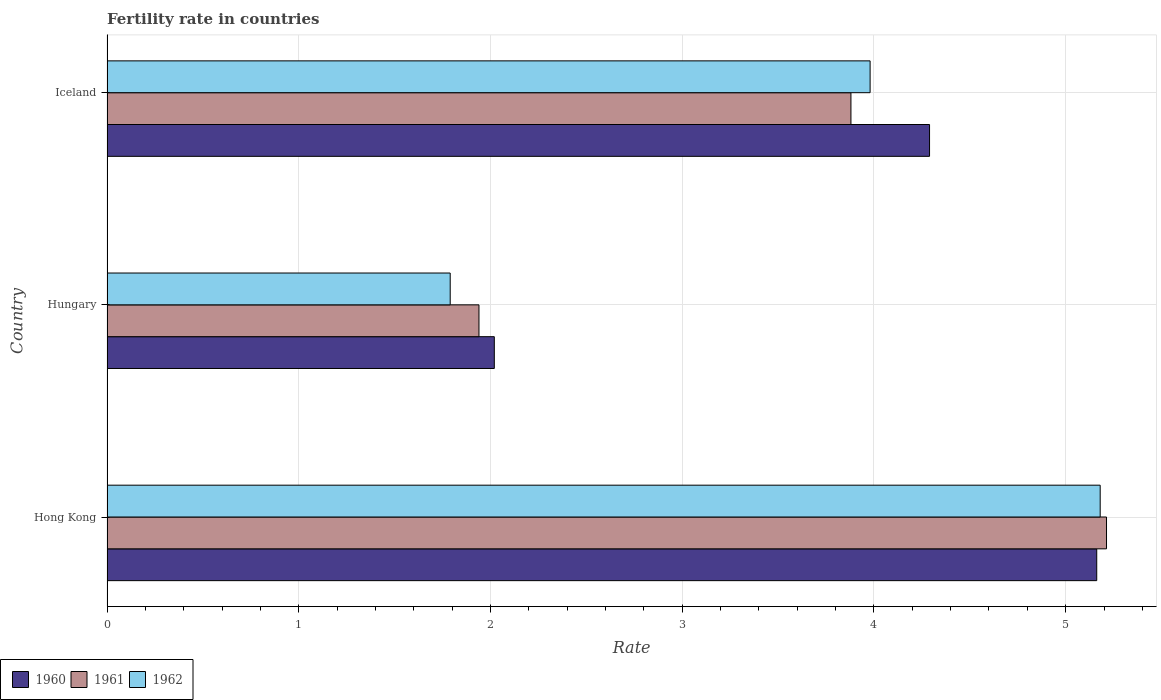How many groups of bars are there?
Your answer should be very brief. 3. How many bars are there on the 1st tick from the top?
Offer a very short reply. 3. How many bars are there on the 3rd tick from the bottom?
Offer a terse response. 3. What is the label of the 3rd group of bars from the top?
Provide a short and direct response. Hong Kong. In how many cases, is the number of bars for a given country not equal to the number of legend labels?
Provide a succinct answer. 0. What is the fertility rate in 1960 in Iceland?
Ensure brevity in your answer.  4.29. Across all countries, what is the maximum fertility rate in 1961?
Ensure brevity in your answer.  5.21. Across all countries, what is the minimum fertility rate in 1960?
Your answer should be very brief. 2.02. In which country was the fertility rate in 1962 maximum?
Your answer should be compact. Hong Kong. In which country was the fertility rate in 1960 minimum?
Provide a succinct answer. Hungary. What is the total fertility rate in 1960 in the graph?
Provide a short and direct response. 11.47. What is the difference between the fertility rate in 1962 in Hong Kong and that in Hungary?
Offer a very short reply. 3.39. What is the difference between the fertility rate in 1962 in Hong Kong and the fertility rate in 1961 in Hungary?
Your answer should be compact. 3.24. What is the average fertility rate in 1962 per country?
Your answer should be very brief. 3.65. What is the difference between the fertility rate in 1962 and fertility rate in 1961 in Hungary?
Provide a succinct answer. -0.15. What is the ratio of the fertility rate in 1962 in Hong Kong to that in Hungary?
Your answer should be very brief. 2.89. Is the fertility rate in 1961 in Hong Kong less than that in Iceland?
Provide a succinct answer. No. What is the difference between the highest and the second highest fertility rate in 1962?
Your answer should be very brief. 1.2. What is the difference between the highest and the lowest fertility rate in 1962?
Your answer should be compact. 3.39. In how many countries, is the fertility rate in 1960 greater than the average fertility rate in 1960 taken over all countries?
Give a very brief answer. 2. Is the sum of the fertility rate in 1961 in Hong Kong and Iceland greater than the maximum fertility rate in 1960 across all countries?
Your response must be concise. Yes. What does the 2nd bar from the bottom in Iceland represents?
Offer a very short reply. 1961. How many countries are there in the graph?
Offer a terse response. 3. Are the values on the major ticks of X-axis written in scientific E-notation?
Ensure brevity in your answer.  No. Does the graph contain grids?
Make the answer very short. Yes. How are the legend labels stacked?
Offer a very short reply. Horizontal. What is the title of the graph?
Offer a very short reply. Fertility rate in countries. Does "1965" appear as one of the legend labels in the graph?
Provide a short and direct response. No. What is the label or title of the X-axis?
Your answer should be very brief. Rate. What is the label or title of the Y-axis?
Keep it short and to the point. Country. What is the Rate of 1960 in Hong Kong?
Make the answer very short. 5.16. What is the Rate in 1961 in Hong Kong?
Keep it short and to the point. 5.21. What is the Rate in 1962 in Hong Kong?
Your answer should be compact. 5.18. What is the Rate in 1960 in Hungary?
Your answer should be very brief. 2.02. What is the Rate in 1961 in Hungary?
Your response must be concise. 1.94. What is the Rate in 1962 in Hungary?
Make the answer very short. 1.79. What is the Rate in 1960 in Iceland?
Ensure brevity in your answer.  4.29. What is the Rate in 1961 in Iceland?
Your response must be concise. 3.88. What is the Rate of 1962 in Iceland?
Your response must be concise. 3.98. Across all countries, what is the maximum Rate in 1960?
Give a very brief answer. 5.16. Across all countries, what is the maximum Rate in 1961?
Make the answer very short. 5.21. Across all countries, what is the maximum Rate in 1962?
Your answer should be very brief. 5.18. Across all countries, what is the minimum Rate in 1960?
Provide a succinct answer. 2.02. Across all countries, what is the minimum Rate of 1961?
Offer a terse response. 1.94. Across all countries, what is the minimum Rate in 1962?
Give a very brief answer. 1.79. What is the total Rate in 1960 in the graph?
Offer a terse response. 11.47. What is the total Rate of 1961 in the graph?
Provide a succinct answer. 11.03. What is the total Rate of 1962 in the graph?
Offer a very short reply. 10.95. What is the difference between the Rate of 1960 in Hong Kong and that in Hungary?
Provide a succinct answer. 3.14. What is the difference between the Rate in 1961 in Hong Kong and that in Hungary?
Provide a short and direct response. 3.27. What is the difference between the Rate in 1962 in Hong Kong and that in Hungary?
Offer a very short reply. 3.39. What is the difference between the Rate in 1960 in Hong Kong and that in Iceland?
Keep it short and to the point. 0.87. What is the difference between the Rate in 1961 in Hong Kong and that in Iceland?
Make the answer very short. 1.33. What is the difference between the Rate in 1962 in Hong Kong and that in Iceland?
Offer a very short reply. 1.2. What is the difference between the Rate of 1960 in Hungary and that in Iceland?
Provide a short and direct response. -2.27. What is the difference between the Rate in 1961 in Hungary and that in Iceland?
Ensure brevity in your answer.  -1.94. What is the difference between the Rate in 1962 in Hungary and that in Iceland?
Your answer should be very brief. -2.19. What is the difference between the Rate in 1960 in Hong Kong and the Rate in 1961 in Hungary?
Your response must be concise. 3.22. What is the difference between the Rate in 1960 in Hong Kong and the Rate in 1962 in Hungary?
Offer a terse response. 3.37. What is the difference between the Rate of 1961 in Hong Kong and the Rate of 1962 in Hungary?
Provide a succinct answer. 3.42. What is the difference between the Rate of 1960 in Hong Kong and the Rate of 1961 in Iceland?
Your answer should be very brief. 1.28. What is the difference between the Rate of 1960 in Hong Kong and the Rate of 1962 in Iceland?
Offer a very short reply. 1.18. What is the difference between the Rate in 1961 in Hong Kong and the Rate in 1962 in Iceland?
Offer a very short reply. 1.23. What is the difference between the Rate of 1960 in Hungary and the Rate of 1961 in Iceland?
Provide a short and direct response. -1.86. What is the difference between the Rate in 1960 in Hungary and the Rate in 1962 in Iceland?
Give a very brief answer. -1.96. What is the difference between the Rate in 1961 in Hungary and the Rate in 1962 in Iceland?
Your response must be concise. -2.04. What is the average Rate of 1960 per country?
Offer a very short reply. 3.82. What is the average Rate in 1961 per country?
Your answer should be very brief. 3.68. What is the average Rate of 1962 per country?
Make the answer very short. 3.65. What is the difference between the Rate in 1960 and Rate in 1961 in Hong Kong?
Your answer should be very brief. -0.05. What is the difference between the Rate of 1960 and Rate of 1962 in Hong Kong?
Offer a very short reply. -0.02. What is the difference between the Rate in 1961 and Rate in 1962 in Hong Kong?
Give a very brief answer. 0.03. What is the difference between the Rate in 1960 and Rate in 1961 in Hungary?
Offer a very short reply. 0.08. What is the difference between the Rate of 1960 and Rate of 1962 in Hungary?
Ensure brevity in your answer.  0.23. What is the difference between the Rate of 1961 and Rate of 1962 in Hungary?
Provide a short and direct response. 0.15. What is the difference between the Rate of 1960 and Rate of 1961 in Iceland?
Provide a short and direct response. 0.41. What is the difference between the Rate in 1960 and Rate in 1962 in Iceland?
Provide a short and direct response. 0.31. What is the ratio of the Rate of 1960 in Hong Kong to that in Hungary?
Provide a succinct answer. 2.56. What is the ratio of the Rate in 1961 in Hong Kong to that in Hungary?
Your answer should be compact. 2.69. What is the ratio of the Rate of 1962 in Hong Kong to that in Hungary?
Keep it short and to the point. 2.89. What is the ratio of the Rate in 1960 in Hong Kong to that in Iceland?
Provide a succinct answer. 1.2. What is the ratio of the Rate of 1961 in Hong Kong to that in Iceland?
Your answer should be very brief. 1.34. What is the ratio of the Rate in 1962 in Hong Kong to that in Iceland?
Your answer should be compact. 1.3. What is the ratio of the Rate of 1960 in Hungary to that in Iceland?
Ensure brevity in your answer.  0.47. What is the ratio of the Rate of 1961 in Hungary to that in Iceland?
Make the answer very short. 0.5. What is the ratio of the Rate of 1962 in Hungary to that in Iceland?
Give a very brief answer. 0.45. What is the difference between the highest and the second highest Rate of 1960?
Ensure brevity in your answer.  0.87. What is the difference between the highest and the second highest Rate in 1961?
Your response must be concise. 1.33. What is the difference between the highest and the lowest Rate of 1960?
Offer a very short reply. 3.14. What is the difference between the highest and the lowest Rate of 1961?
Your answer should be very brief. 3.27. What is the difference between the highest and the lowest Rate of 1962?
Provide a succinct answer. 3.39. 